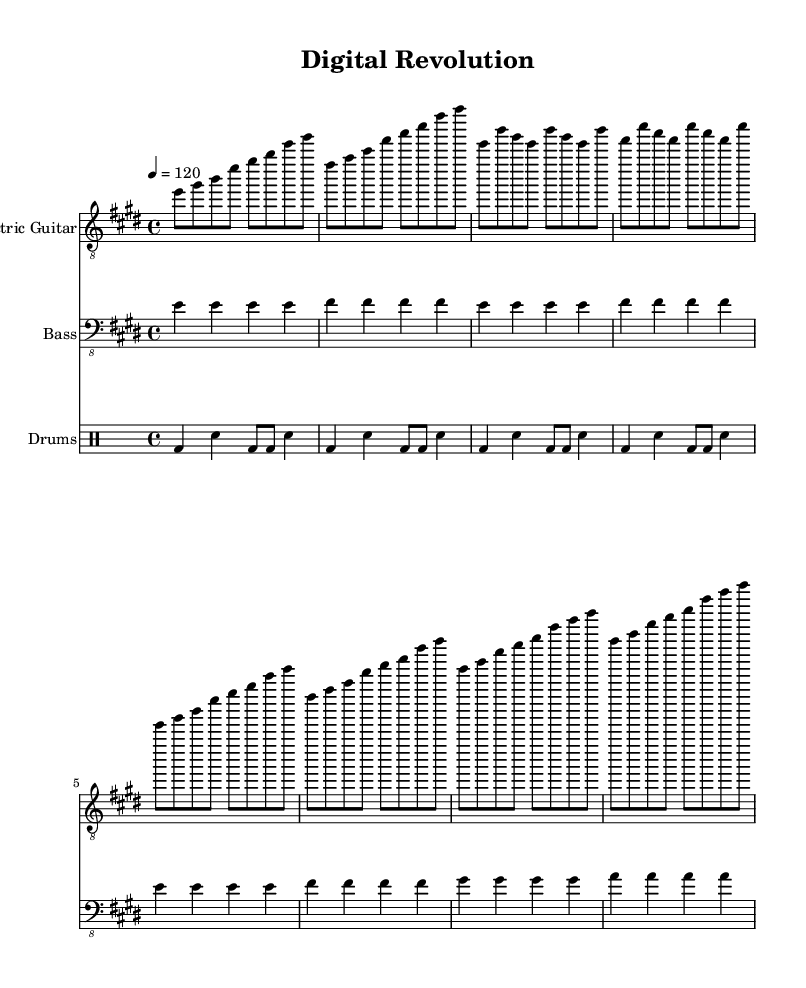What is the key signature of this music? The key signature is E major, which has four sharps: F#, C#, G#, and D#. This is indicated at the beginning of the sheet music.
Answer: E major What is the time signature of this music? The time signature is 4/4, meaning there are four beats in each measure and a quarter note receives one beat. This is shown at the beginning of the score.
Answer: 4/4 What is the tempo marking for this piece? The tempo marking is quarter note equals 120, indicating the speed of the music. This is specified in the header section of the sheet music.
Answer: 120 How many measures are in the verse section? The verse section consists of 4 measures, as indicated by the repeating pattern of notes in that section of the score. Each line of the verse corresponds to one measure.
Answer: 4 What is the repeated chord in the chorus? The repeated chord in the chorus is E major, which is the first chord played and is evident as the driving force in the chorus structure. This chord is indicated at the start of the chorus section on the electric guitar staff.
Answer: E major How does the bass line differ between the verse and chorus? The bass line plays E notes in the verse and adds F# notes in the chorus, providing a harmonic foundation that differs between the two song sections. This is observed through the notation in each corresponding section of the score.
Answer: E and F# What is the primary rhythm pattern utilized in the drums? The primary rhythm pattern utilized in the drums is a basic rock beat, which consists of a kick drum on beats 1 and 3, and a snare on beats 2 and 4. This is visible in the drumming notation under the drum staff.
Answer: Basic rock beat 